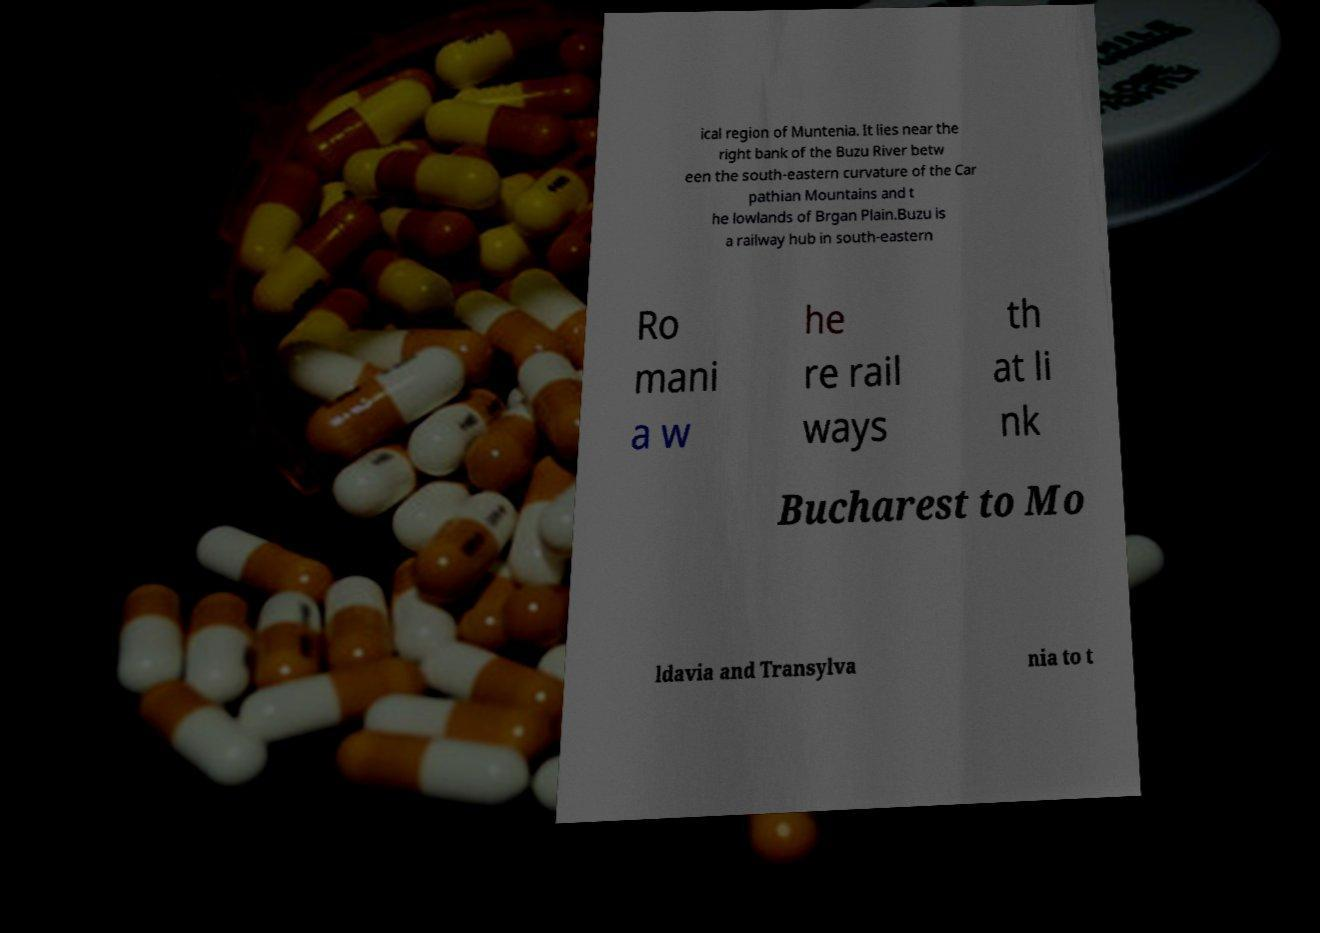Please read and relay the text visible in this image. What does it say? ical region of Muntenia. It lies near the right bank of the Buzu River betw een the south-eastern curvature of the Car pathian Mountains and t he lowlands of Brgan Plain.Buzu is a railway hub in south-eastern Ro mani a w he re rail ways th at li nk Bucharest to Mo ldavia and Transylva nia to t 